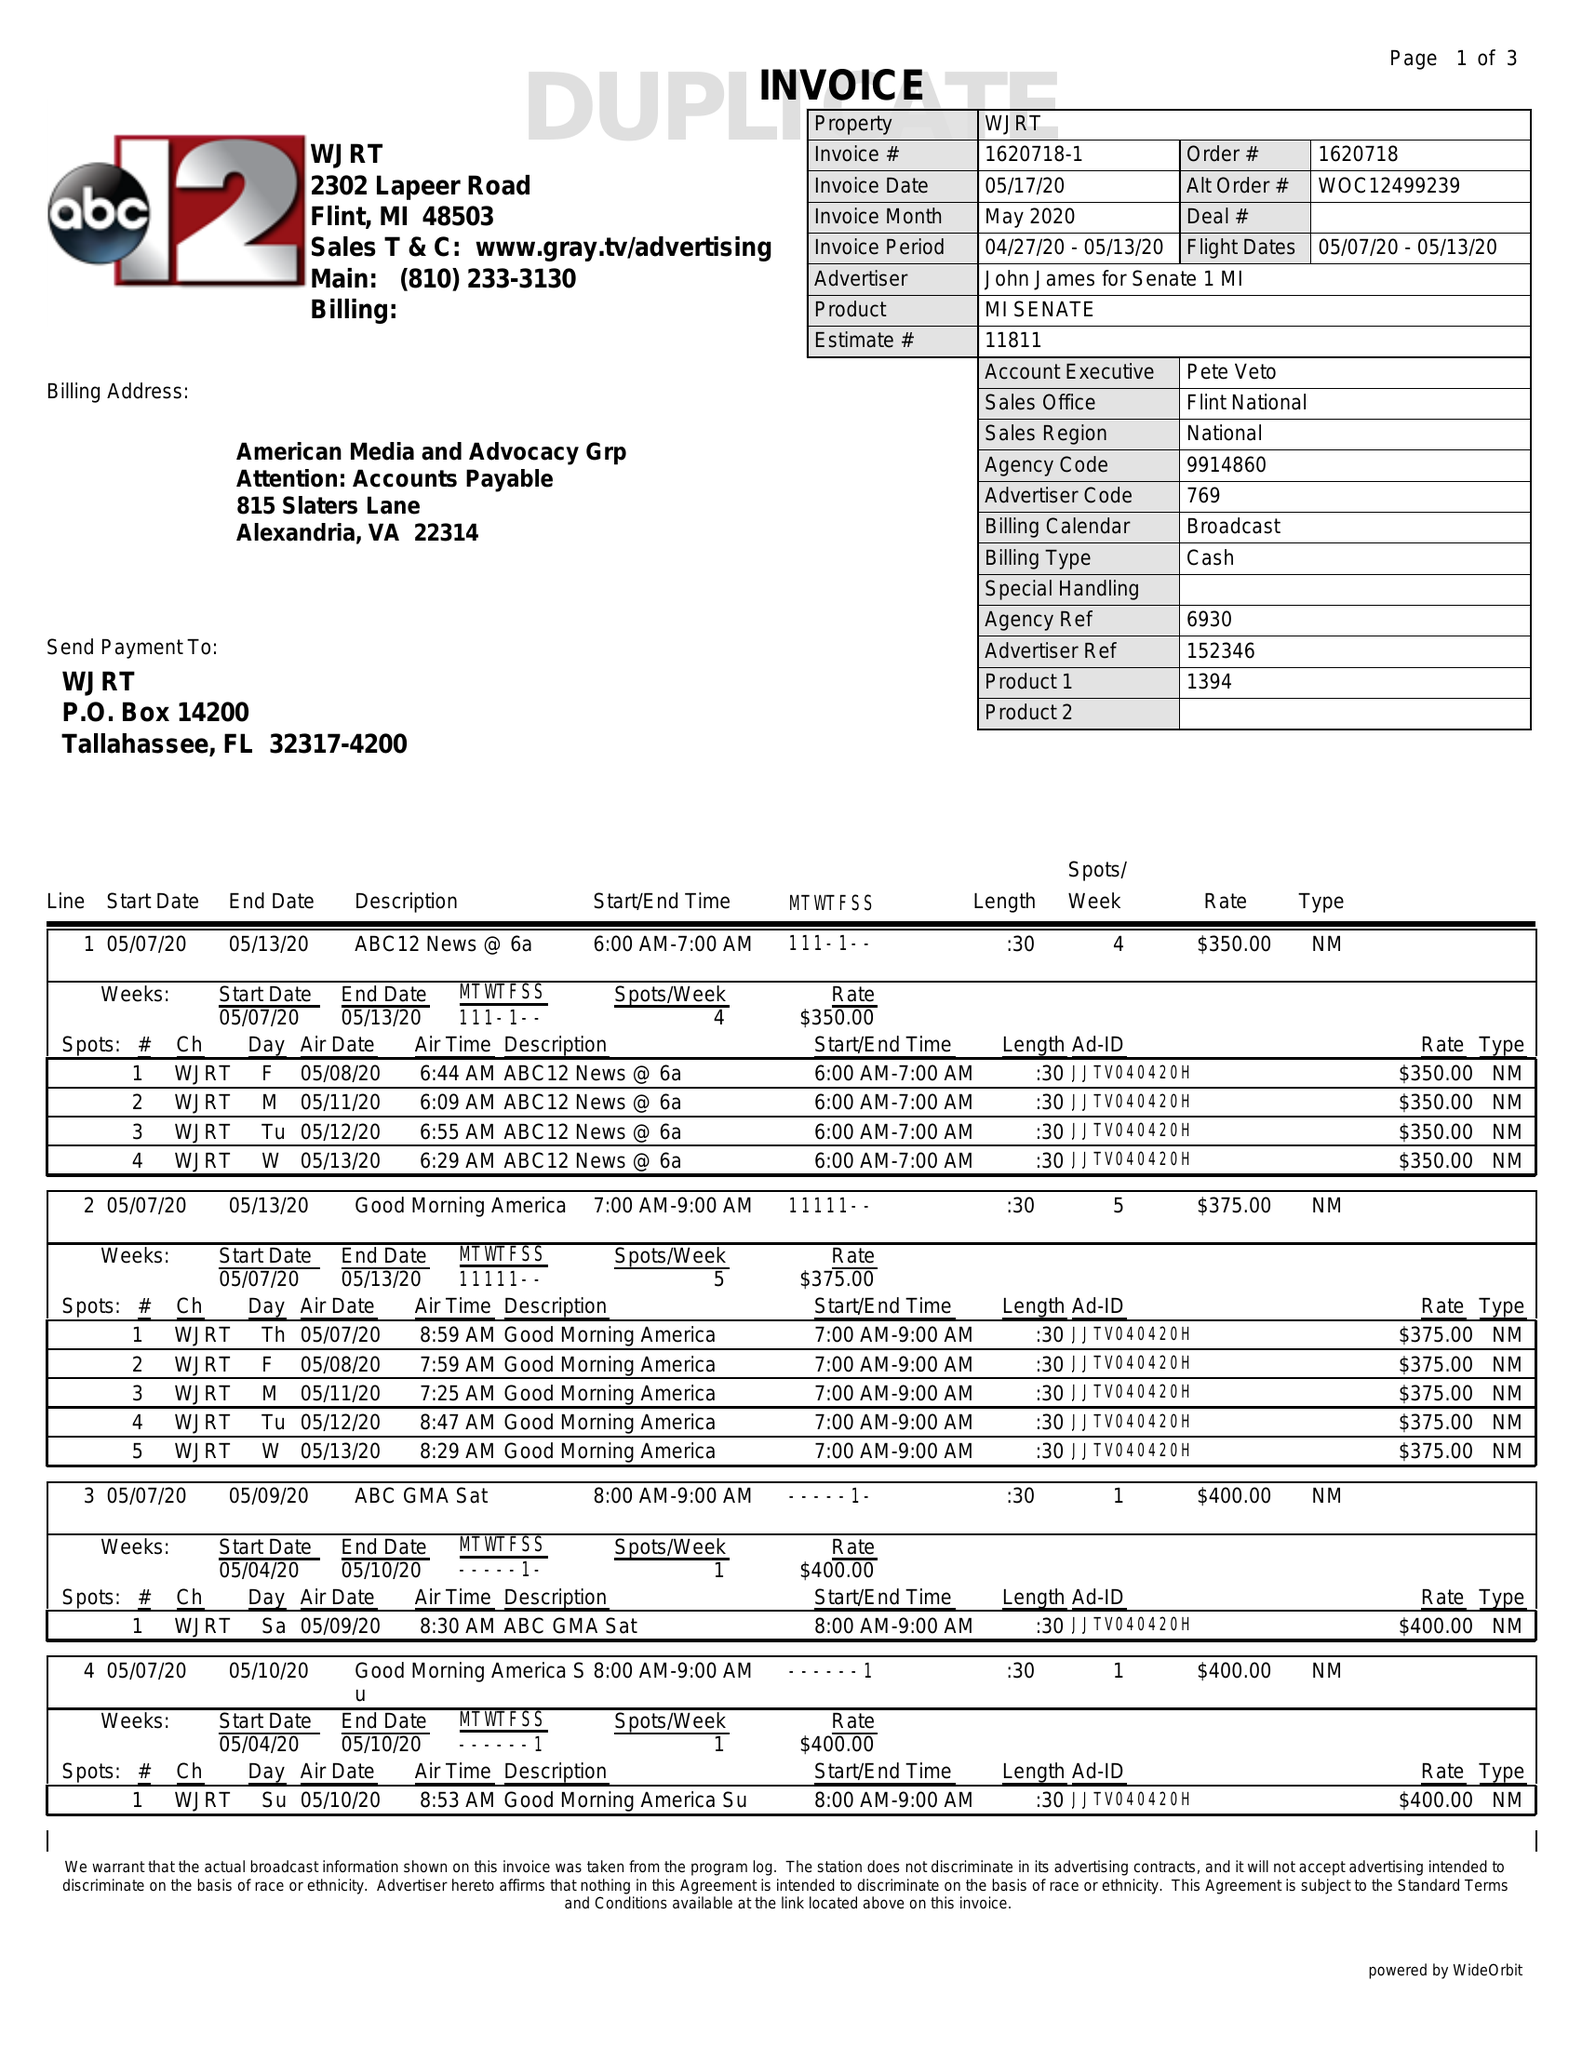What is the value for the flight_to?
Answer the question using a single word or phrase. 05/13/20 